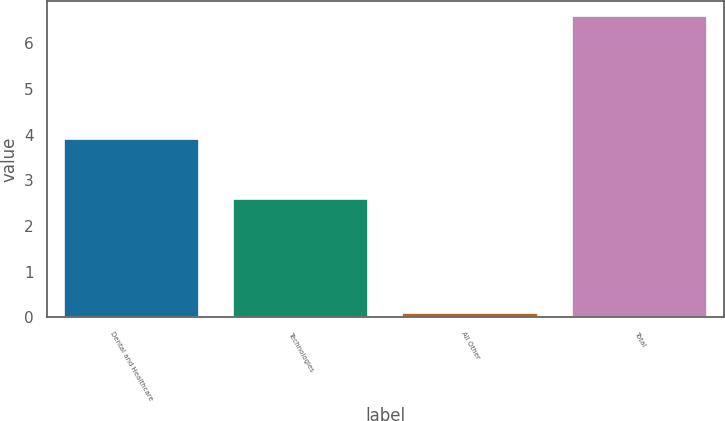Convert chart. <chart><loc_0><loc_0><loc_500><loc_500><bar_chart><fcel>Dental and Healthcare<fcel>Technologies<fcel>All Other<fcel>Total<nl><fcel>3.9<fcel>2.6<fcel>0.1<fcel>6.6<nl></chart> 